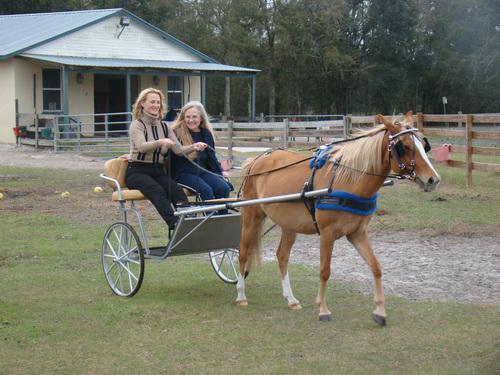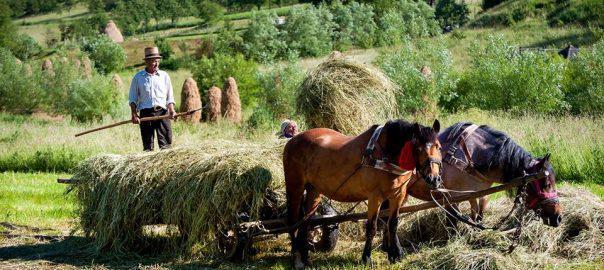The first image is the image on the left, the second image is the image on the right. For the images displayed, is the sentence "Horses are transporting people in both images." factually correct? Answer yes or no. No. The first image is the image on the left, the second image is the image on the right. Evaluate the accuracy of this statement regarding the images: "One image shows a leftward-facing pony with a white mane hitched to a two-wheeled cart carrying one woman in a hat.". Is it true? Answer yes or no. No. 